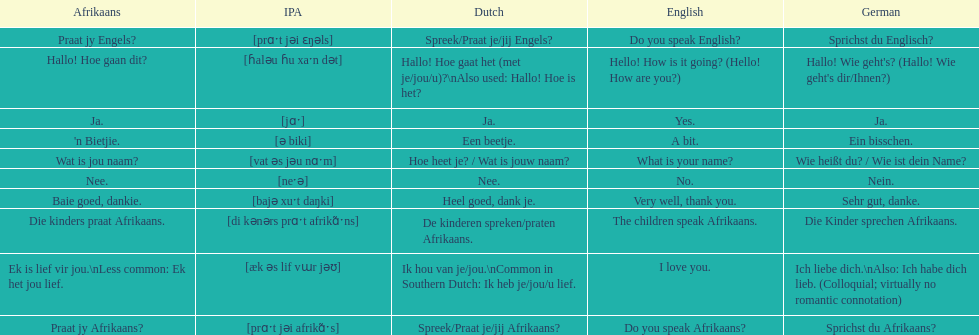Translate the following into english: 'n bietjie. A bit. 